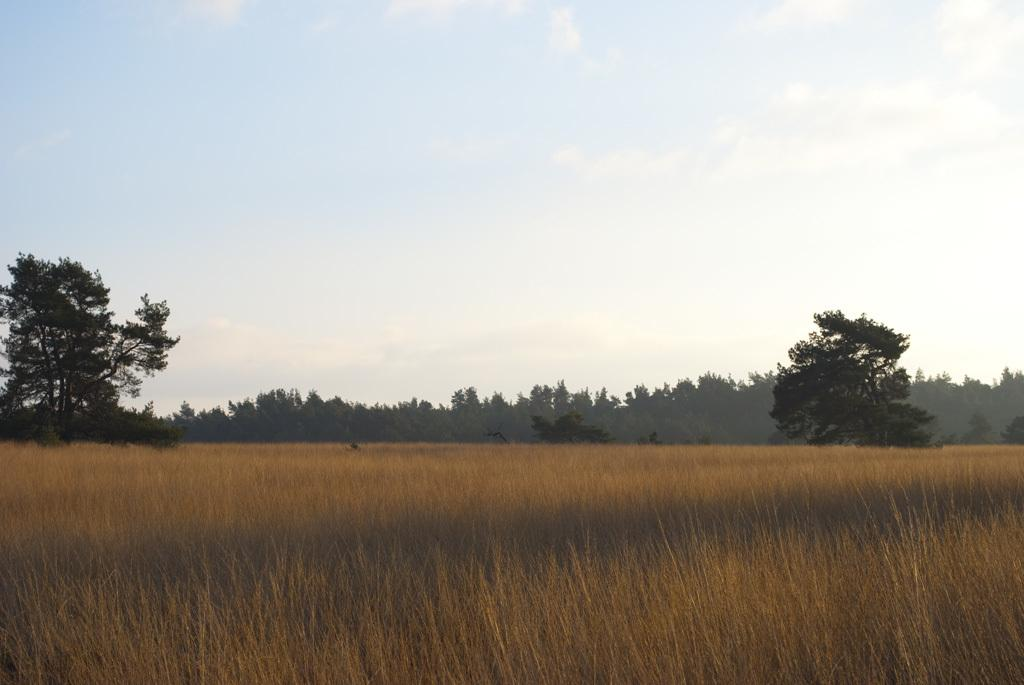What type of terrain is at the bottom of the image? There is a field at the bottom of the image. What is the field made of? The field contains grass. What is visible at the top of the image? The sky is visible at the top of the image. What can be seen in the background of the image? There are trees in the background of the image. What type of steel structure can be seen in the image? There is no steel structure present in the image; it features a field, grass, sky, and trees. How does the mask protect the trees during the rainstorm in the image? There is no rainstorm or mask present in the image; it only shows a field, grass, sky, and trees. 